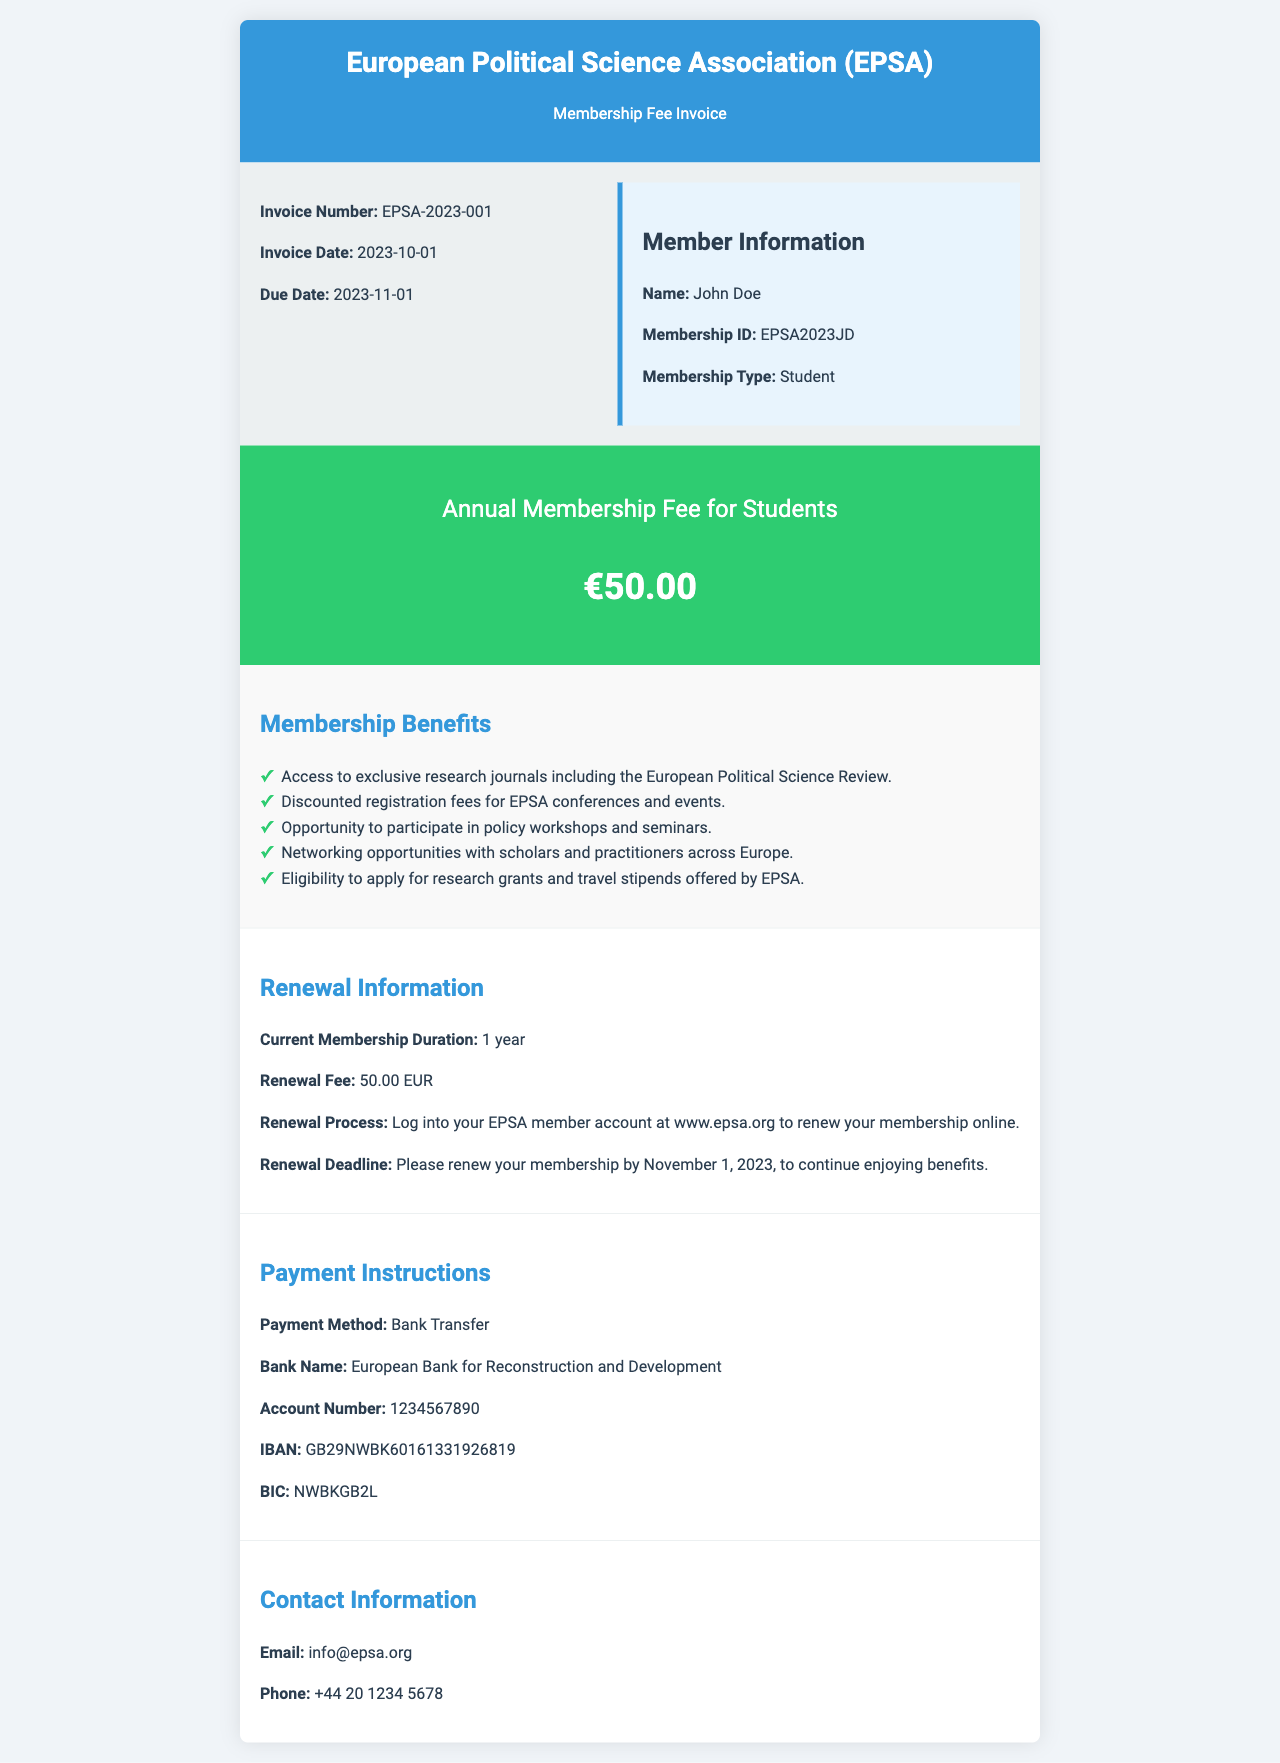What is the invoice number? The invoice number is clearly stated in the document as a unique identifier for this invoice.
Answer: EPSA-2023-001 What is the due date for the invoice? The due date is important for members to know when payment needs to be made.
Answer: 2023-11-01 Who is the member listed on the invoice? The member's name is provided to personalize the invoice and ensure accurate record-keeping.
Answer: John Doe What is the membership fee for students? The membership fee is highlighted in the fee section of the document for clarity.
Answer: €50.00 What is one of the benefits of membership? The document lists multiple benefits that come with membership, demonstrating the value of joining.
Answer: Access to exclusive research journals including the European Political Science Review What is the renewal information related to the membership? This section outlines key details regarding the renewal process for members to continue their membership.
Answer: Please renew your membership by November 1, 2023, to continue enjoying benefits What is the payment method indicated in the document? The payment method specifies how the member should pay the membership fee.
Answer: Bank Transfer What is the contact email for EPSA? Providing a contact email allows members to reach out for assistance or inquiries.
Answer: info@epsa.org 